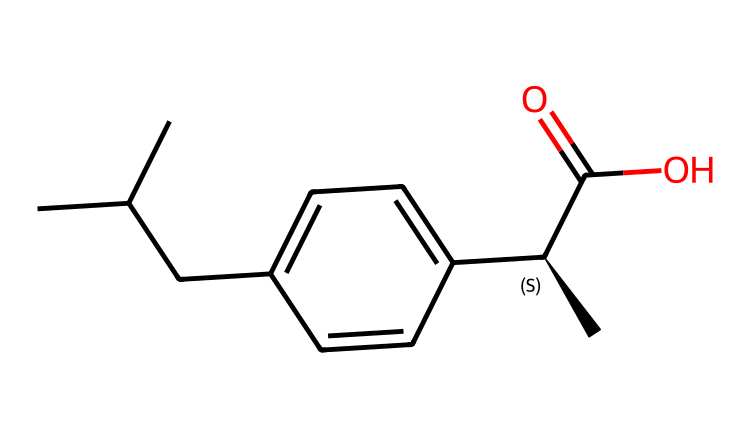What is the molecular formula of ibuprofen? To derive the molecular formula, we count the number of each type of atom represented in the SMILES. In this case, we identify 13 carbon atoms, 18 hydrogen atoms, and 2 oxygen atoms. Therefore, the molecular formula is C13H18O2.
Answer: C13H18O2 How many stereocenters are present in ibuprofen? In the chemical structure of ibuprofen, we look for carbon atoms bonded to four different groups. The only stereocenter present is at the carbon indicated with the '@' symbol in the SMILES representation. This means there's one stereocenter.
Answer: 1 What functional group is indicative of ibuprofen's acidity? The -COOH group (carboxylic acid) is clearly identifiable in the chemical structure. This functional group is responsible for the acidic nature of ibuprofen.
Answer: carboxylic acid What is the total number of rings in the ibuprofen molecule? Observing the chemical structure reveals that there are no cyclic structures present. The compound is composed of a linear chain with an aromatic ring; however, this does not count as a full ring. Therefore, the total number of rings is zero.
Answer: 0 Which part of the ibuprofen molecule contributes to its anti-inflammatory properties? The presence of the carboxylic acid (–COOH) and the aromatic ring interactions are key contributors to its anti-inflammatory effects, as this structure helps inhibit enzymes involved in inflammation.
Answer: carboxylic acid and aromatic ring What is the significance of the chiral center in ibuprofen concerning its pharmacological action? The chiral center in ibuprofen affects its pharmacological function because the two enantiomers (mirror images) exhibit different biological activities. One enantiomer is more effective as a pain reliever than the other, which is important in determining dosage and effects.
Answer: enantiomers 